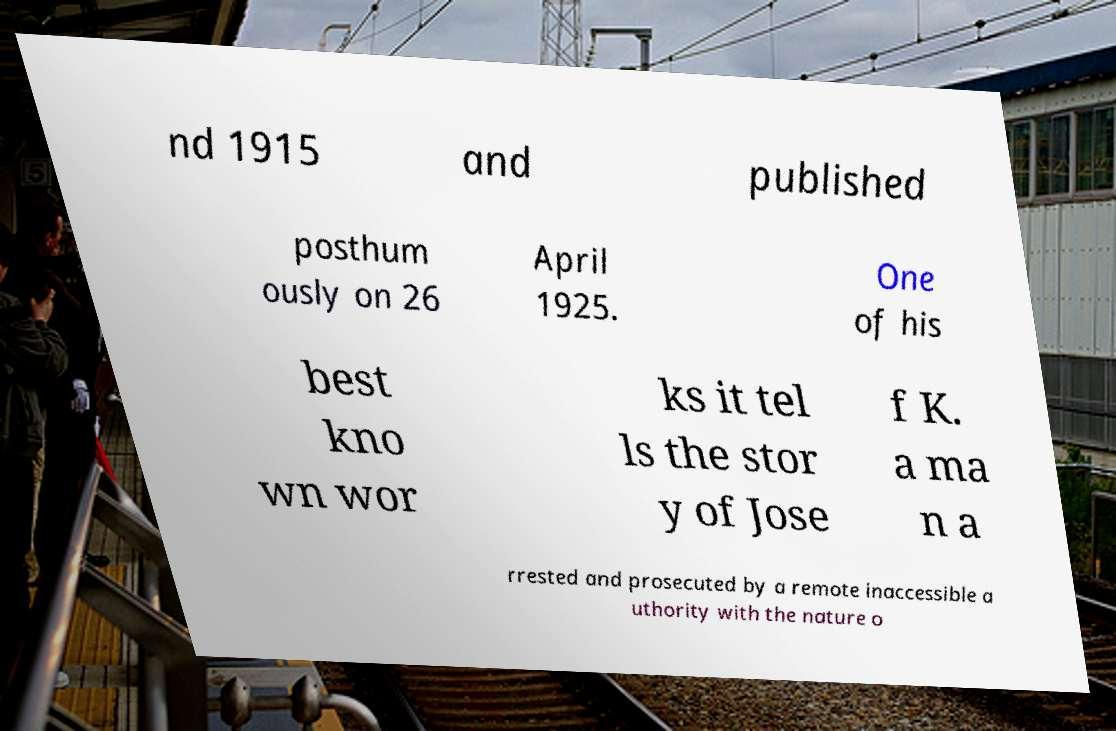I need the written content from this picture converted into text. Can you do that? nd 1915 and published posthum ously on 26 April 1925. One of his best kno wn wor ks it tel ls the stor y of Jose f K. a ma n a rrested and prosecuted by a remote inaccessible a uthority with the nature o 